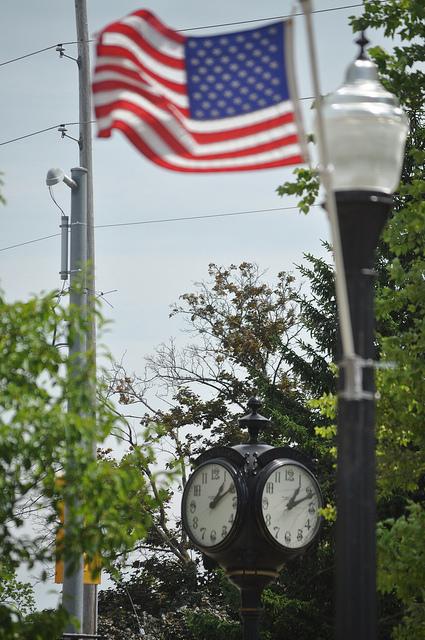What is on the pole in the very back?
Answer briefly. Wires. What country was this photo taken in?
Give a very brief answer. United states. What is the wind like today?
Keep it brief. Windy. 